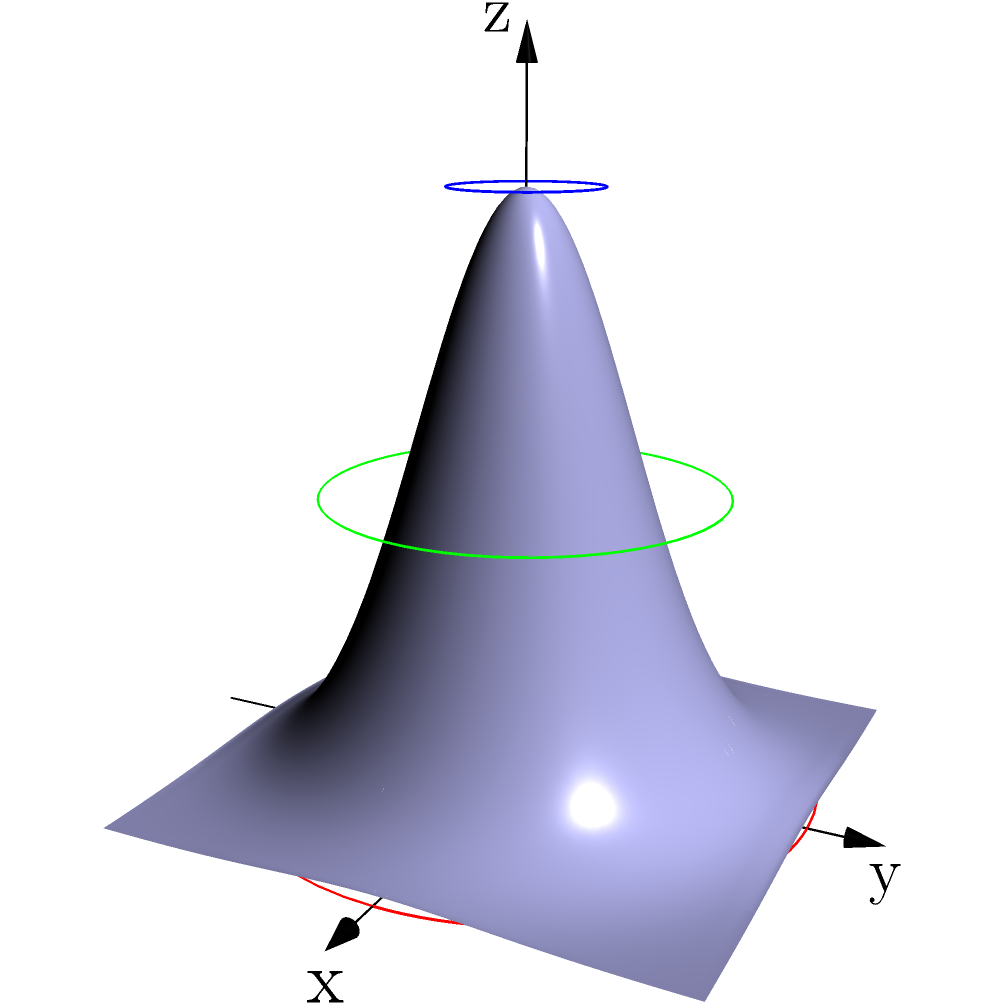A solid object is formed by rotating the function $z = 2e^{-x^2-y^2}$ around the z-axis. The cross-sectional area of this object at any height $z$ can be described by $A(z) = \pi r^2$, where $r$ is the radius of the circular cross-section at that height. Given that the maximum height of the object is 2 units, determine the equation for $A(z)$ in terms of $z$, and calculate the cross-sectional areas at $z = 0$, $z = 1$, and $z = 2$. To solve this problem, we'll follow these steps:

1) First, we need to find the relationship between $z$ and $r$. From the given function:

   $z = 2e^{-x^2-y^2}$

2) At any point on the surface, $x^2 + y^2 = r^2$. Substituting this:

   $z = 2e^{-r^2}$

3) To express $r$ in terms of $z$, we solve this equation for $r$:

   $\frac{z}{2} = e^{-r^2}$
   $\ln(\frac{z}{2}) = -r^2$
   $r^2 = -\ln(\frac{z}{2})$
   $r = \sqrt{-\ln(\frac{z}{2})}$

4) Now we can express the cross-sectional area $A(z)$ in terms of $z$:

   $A(z) = \pi r^2 = \pi (-\ln(\frac{z}{2}))$

5) To calculate the areas at specific heights:

   At $z = 0$: 
   $A(0) = \pi (-\ln(\frac{0}{2}))$ is undefined (the base of the object)

   At $z = 1$:
   $A(1) = \pi (-\ln(\frac{1}{2})) = \pi \ln(2) \approx 2.18\pi$

   At $z = 2$:
   $A(2) = \pi (-\ln(\frac{2}{2})) = \pi (-\ln(1)) = 0$

Therefore, the cross-sectional area decreases from the base to the top of the object, becoming a point at the maximum height.
Answer: $A(z) = \pi (-\ln(\frac{z}{2}))$; $A(1) \approx 2.18\pi$; $A(2) = 0$ 